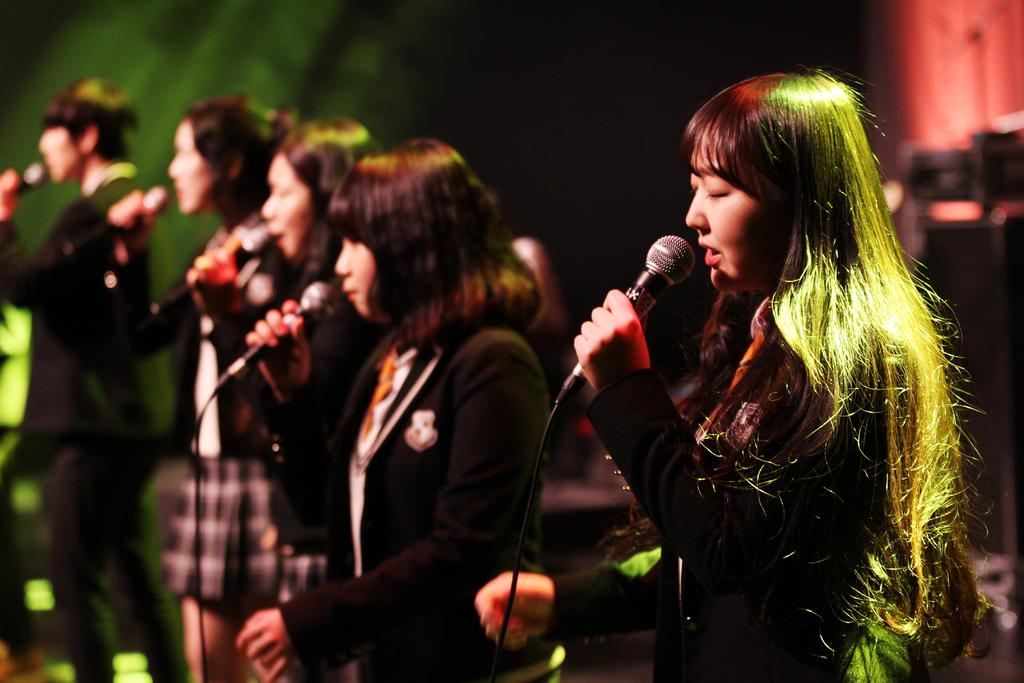Who are the people in the image? There are women and a man in the image. Where are they standing? They are standing on a dais. What are they doing? They are singing. What are they using to amplify their voices? Microphones are being used by the individuals. What type of dog is sitting next to the man in the image? There is no dog present in the image; it features only the women and the man. What is the income of the individuals in the image? The income of the individuals in the image cannot be determined from the image itself. 